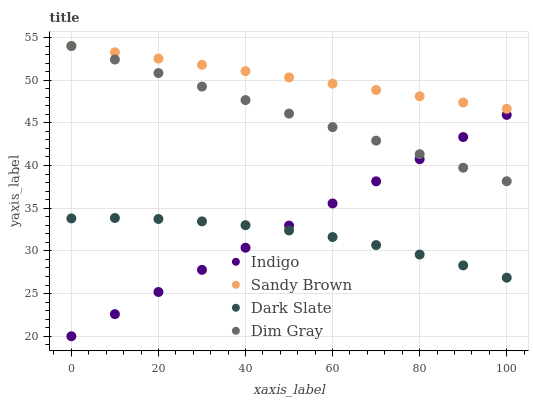Does Dark Slate have the minimum area under the curve?
Answer yes or no. Yes. Does Sandy Brown have the maximum area under the curve?
Answer yes or no. Yes. Does Dim Gray have the minimum area under the curve?
Answer yes or no. No. Does Dim Gray have the maximum area under the curve?
Answer yes or no. No. Is Sandy Brown the smoothest?
Answer yes or no. Yes. Is Dark Slate the roughest?
Answer yes or no. Yes. Is Dim Gray the smoothest?
Answer yes or no. No. Is Dim Gray the roughest?
Answer yes or no. No. Does Indigo have the lowest value?
Answer yes or no. Yes. Does Dim Gray have the lowest value?
Answer yes or no. No. Does Dim Gray have the highest value?
Answer yes or no. Yes. Does Indigo have the highest value?
Answer yes or no. No. Is Indigo less than Sandy Brown?
Answer yes or no. Yes. Is Sandy Brown greater than Dark Slate?
Answer yes or no. Yes. Does Indigo intersect Dim Gray?
Answer yes or no. Yes. Is Indigo less than Dim Gray?
Answer yes or no. No. Is Indigo greater than Dim Gray?
Answer yes or no. No. Does Indigo intersect Sandy Brown?
Answer yes or no. No. 